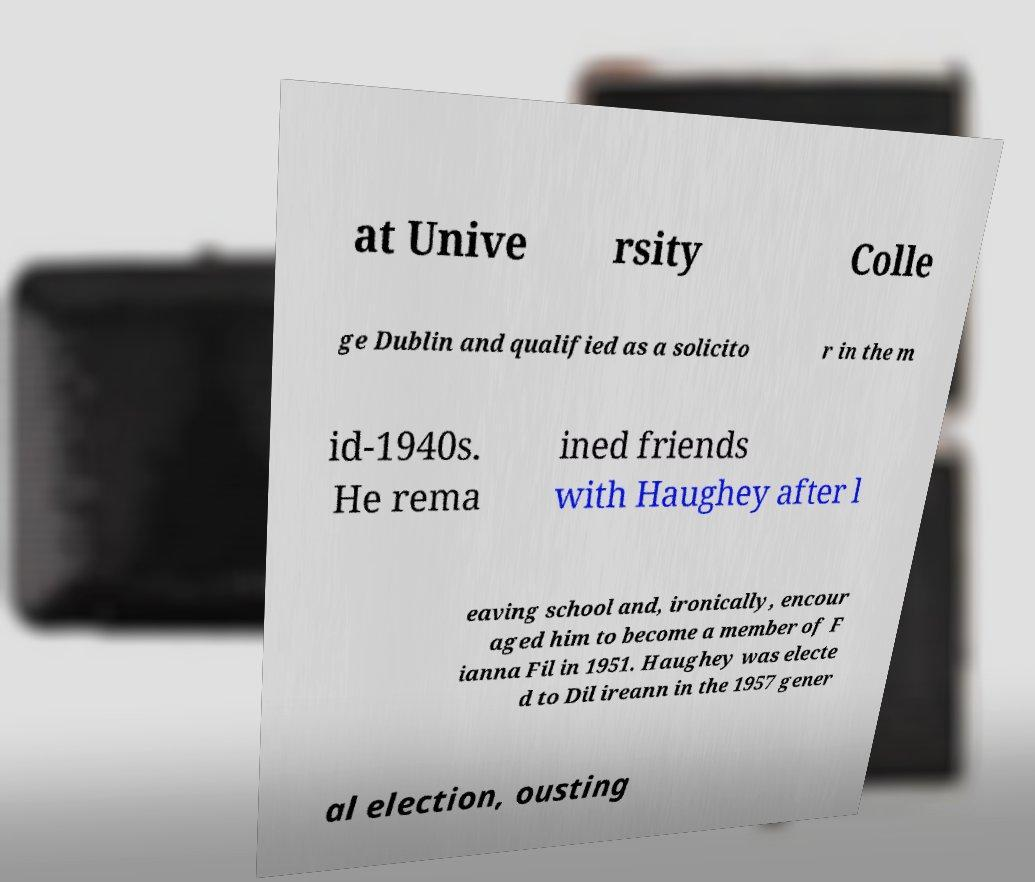Could you assist in decoding the text presented in this image and type it out clearly? at Unive rsity Colle ge Dublin and qualified as a solicito r in the m id-1940s. He rema ined friends with Haughey after l eaving school and, ironically, encour aged him to become a member of F ianna Fil in 1951. Haughey was electe d to Dil ireann in the 1957 gener al election, ousting 